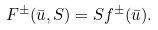<formula> <loc_0><loc_0><loc_500><loc_500>F ^ { \pm } ( \bar { u } , S ) = S f ^ { \pm } ( \bar { u } ) .</formula> 